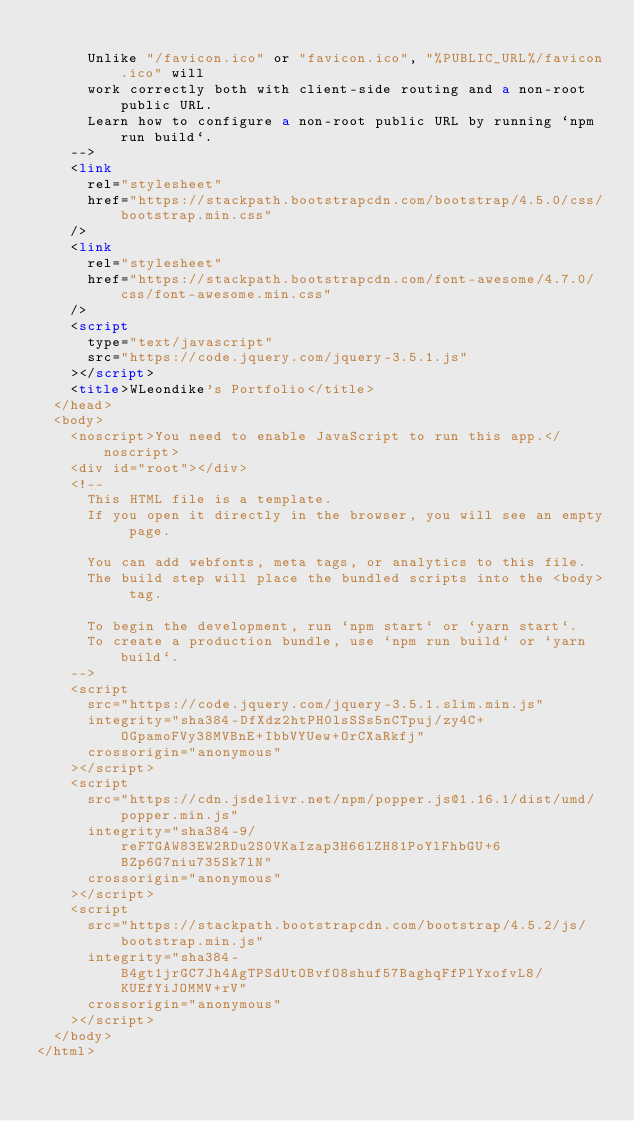Convert code to text. <code><loc_0><loc_0><loc_500><loc_500><_HTML_>
      Unlike "/favicon.ico" or "favicon.ico", "%PUBLIC_URL%/favicon.ico" will
      work correctly both with client-side routing and a non-root public URL.
      Learn how to configure a non-root public URL by running `npm run build`.
    -->
    <link
      rel="stylesheet"
      href="https://stackpath.bootstrapcdn.com/bootstrap/4.5.0/css/bootstrap.min.css"
    />
    <link
      rel="stylesheet"
      href="https://stackpath.bootstrapcdn.com/font-awesome/4.7.0/css/font-awesome.min.css"
    />
    <script
      type="text/javascript"
      src="https://code.jquery.com/jquery-3.5.1.js"
    ></script>
    <title>WLeondike's Portfolio</title>
  </head>
  <body>
    <noscript>You need to enable JavaScript to run this app.</noscript>
    <div id="root"></div>
    <!--
      This HTML file is a template.
      If you open it directly in the browser, you will see an empty page.

      You can add webfonts, meta tags, or analytics to this file.
      The build step will place the bundled scripts into the <body> tag.

      To begin the development, run `npm start` or `yarn start`.
      To create a production bundle, use `npm run build` or `yarn build`.
    -->
    <script
      src="https://code.jquery.com/jquery-3.5.1.slim.min.js"
      integrity="sha384-DfXdz2htPH0lsSSs5nCTpuj/zy4C+OGpamoFVy38MVBnE+IbbVYUew+OrCXaRkfj"
      crossorigin="anonymous"
    ></script>
    <script
      src="https://cdn.jsdelivr.net/npm/popper.js@1.16.1/dist/umd/popper.min.js"
      integrity="sha384-9/reFTGAW83EW2RDu2S0VKaIzap3H66lZH81PoYlFhbGU+6BZp6G7niu735Sk7lN"
      crossorigin="anonymous"
    ></script>
    <script
      src="https://stackpath.bootstrapcdn.com/bootstrap/4.5.2/js/bootstrap.min.js"
      integrity="sha384-B4gt1jrGC7Jh4AgTPSdUtOBvfO8shuf57BaghqFfPlYxofvL8/KUEfYiJOMMV+rV"
      crossorigin="anonymous"
    ></script>
  </body>
</html>
</code> 